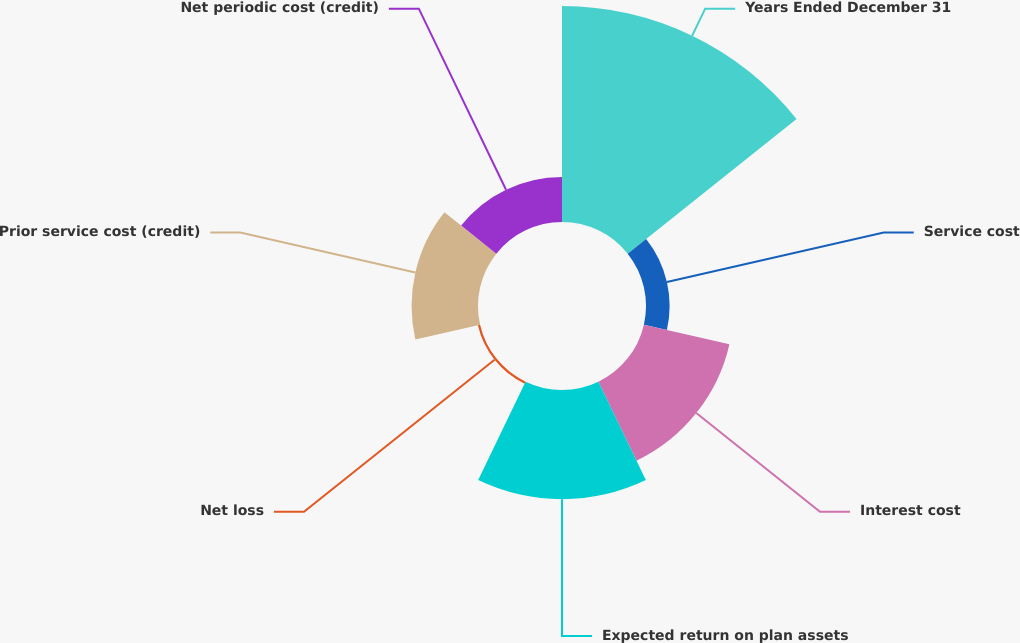<chart> <loc_0><loc_0><loc_500><loc_500><pie_chart><fcel>Years Ended December 31<fcel>Service cost<fcel>Interest cost<fcel>Expected return on plan assets<fcel>Net loss<fcel>Prior service cost (credit)<fcel>Net periodic cost (credit)<nl><fcel>39.26%<fcel>4.29%<fcel>15.95%<fcel>19.84%<fcel>0.41%<fcel>12.07%<fcel>8.18%<nl></chart> 